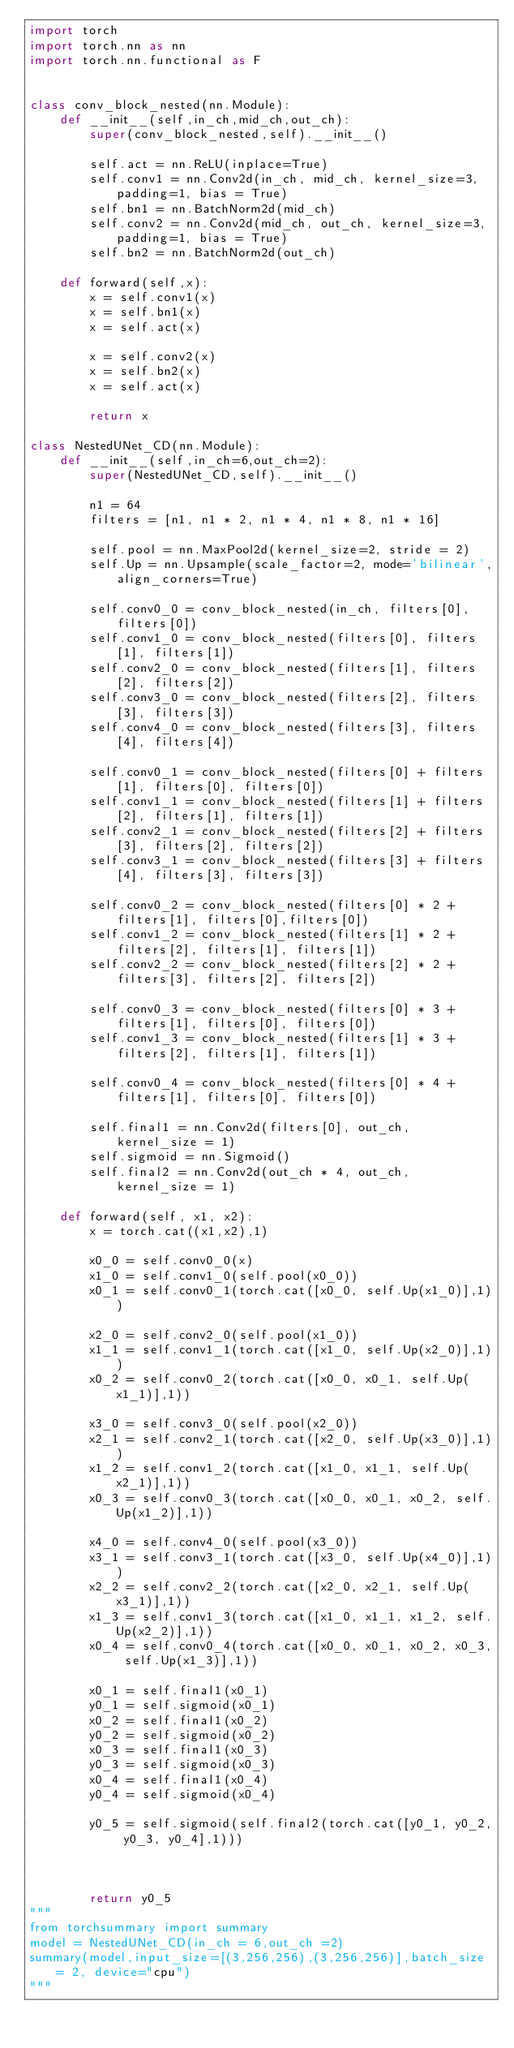Convert code to text. <code><loc_0><loc_0><loc_500><loc_500><_Python_>import torch
import torch.nn as nn
import torch.nn.functional as F


class conv_block_nested(nn.Module):
    def __init__(self,in_ch,mid_ch,out_ch):
        super(conv_block_nested,self).__init__()
        
        self.act = nn.ReLU(inplace=True)
        self.conv1 = nn.Conv2d(in_ch, mid_ch, kernel_size=3, padding=1, bias = True)
        self.bn1 = nn.BatchNorm2d(mid_ch)
        self.conv2 = nn.Conv2d(mid_ch, out_ch, kernel_size=3, padding=1, bias = True)
        self.bn2 = nn.BatchNorm2d(out_ch)
        
    def forward(self,x):
        x = self.conv1(x)
        x = self.bn1(x)
        x = self.act(x)
        
        x = self.conv2(x)
        x = self.bn2(x)
        x = self.act(x)
        
        return x
    
class NestedUNet_CD(nn.Module):
    def __init__(self,in_ch=6,out_ch=2):
        super(NestedUNet_CD,self).__init__()
        
        n1 = 64
        filters = [n1, n1 * 2, n1 * 4, n1 * 8, n1 * 16]
        
        self.pool = nn.MaxPool2d(kernel_size=2, stride = 2)
        self.Up = nn.Upsample(scale_factor=2, mode='bilinear',align_corners=True)
        
        self.conv0_0 = conv_block_nested(in_ch, filters[0], filters[0])
        self.conv1_0 = conv_block_nested(filters[0], filters[1], filters[1])
        self.conv2_0 = conv_block_nested(filters[1], filters[2], filters[2])
        self.conv3_0 = conv_block_nested(filters[2], filters[3], filters[3])
        self.conv4_0 = conv_block_nested(filters[3], filters[4], filters[4])
        
        self.conv0_1 = conv_block_nested(filters[0] + filters[1], filters[0], filters[0])
        self.conv1_1 = conv_block_nested(filters[1] + filters[2], filters[1], filters[1])
        self.conv2_1 = conv_block_nested(filters[2] + filters[3], filters[2], filters[2])
        self.conv3_1 = conv_block_nested(filters[3] + filters[4], filters[3], filters[3])
        
        self.conv0_2 = conv_block_nested(filters[0] * 2 + filters[1], filters[0],filters[0])
        self.conv1_2 = conv_block_nested(filters[1] * 2 + filters[2], filters[1], filters[1])
        self.conv2_2 = conv_block_nested(filters[2] * 2 + filters[3], filters[2], filters[2])
        
        self.conv0_3 = conv_block_nested(filters[0] * 3 + filters[1], filters[0], filters[0])
        self.conv1_3 = conv_block_nested(filters[1] * 3 + filters[2], filters[1], filters[1])
        
        self.conv0_4 = conv_block_nested(filters[0] * 4 + filters[1], filters[0], filters[0])
        
        self.final1 = nn.Conv2d(filters[0], out_ch, kernel_size = 1)
        self.sigmoid = nn.Sigmoid()
        self.final2 = nn.Conv2d(out_ch * 4, out_ch, kernel_size = 1)
        
    def forward(self, x1, x2):
        x = torch.cat((x1,x2),1)
        
        x0_0 = self.conv0_0(x)
        x1_0 = self.conv1_0(self.pool(x0_0))
        x0_1 = self.conv0_1(torch.cat([x0_0, self.Up(x1_0)],1))
        
        x2_0 = self.conv2_0(self.pool(x1_0))
        x1_1 = self.conv1_1(torch.cat([x1_0, self.Up(x2_0)],1))
        x0_2 = self.conv0_2(torch.cat([x0_0, x0_1, self.Up(x1_1)],1))
        
        x3_0 = self.conv3_0(self.pool(x2_0))
        x2_1 = self.conv2_1(torch.cat([x2_0, self.Up(x3_0)],1))
        x1_2 = self.conv1_2(torch.cat([x1_0, x1_1, self.Up(x2_1)],1))
        x0_3 = self.conv0_3(torch.cat([x0_0, x0_1, x0_2, self.Up(x1_2)],1))
    
        x4_0 = self.conv4_0(self.pool(x3_0))
        x3_1 = self.conv3_1(torch.cat([x3_0, self.Up(x4_0)],1))
        x2_2 = self.conv2_2(torch.cat([x2_0, x2_1, self.Up(x3_1)],1))
        x1_3 = self.conv1_3(torch.cat([x1_0, x1_1, x1_2, self.Up(x2_2)],1))
        x0_4 = self.conv0_4(torch.cat([x0_0, x0_1, x0_2, x0_3, self.Up(x1_3)],1))
        
        x0_1 = self.final1(x0_1)
        y0_1 = self.sigmoid(x0_1)
        x0_2 = self.final1(x0_2)
        y0_2 = self.sigmoid(x0_2)
        x0_3 = self.final1(x0_3)
        y0_3 = self.sigmoid(x0_3)
        x0_4 = self.final1(x0_4)
        y0_4 = self.sigmoid(x0_4)
        
        y0_5 = self.sigmoid(self.final2(torch.cat([y0_1, y0_2, y0_3, y0_4],1)))
        
        
        
        return y0_5
"""    
from torchsummary import summary
model = NestedUNet_CD(in_ch = 6,out_ch =2)
summary(model,input_size=[(3,256,256),(3,256,256)],batch_size = 2, device="cpu")
"""</code> 